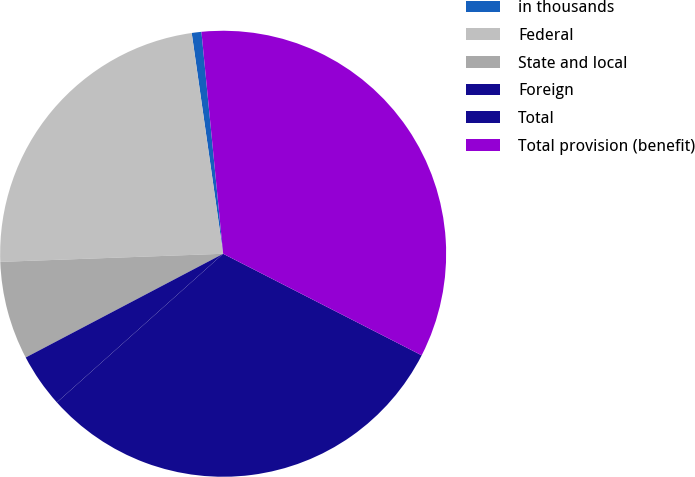Convert chart to OTSL. <chart><loc_0><loc_0><loc_500><loc_500><pie_chart><fcel>in thousands<fcel>Federal<fcel>State and local<fcel>Foreign<fcel>Total<fcel>Total provision (benefit)<nl><fcel>0.7%<fcel>23.33%<fcel>7.12%<fcel>3.91%<fcel>30.87%<fcel>34.08%<nl></chart> 